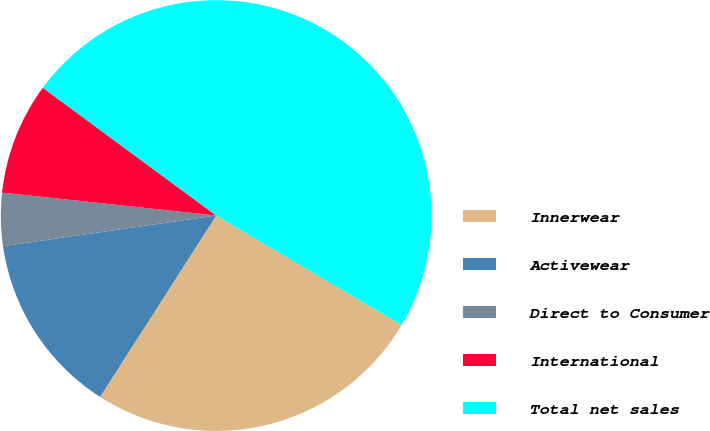Convert chart to OTSL. <chart><loc_0><loc_0><loc_500><loc_500><pie_chart><fcel>Innerwear<fcel>Activewear<fcel>Direct to Consumer<fcel>International<fcel>Total net sales<nl><fcel>25.56%<fcel>13.66%<fcel>3.97%<fcel>8.41%<fcel>48.38%<nl></chart> 